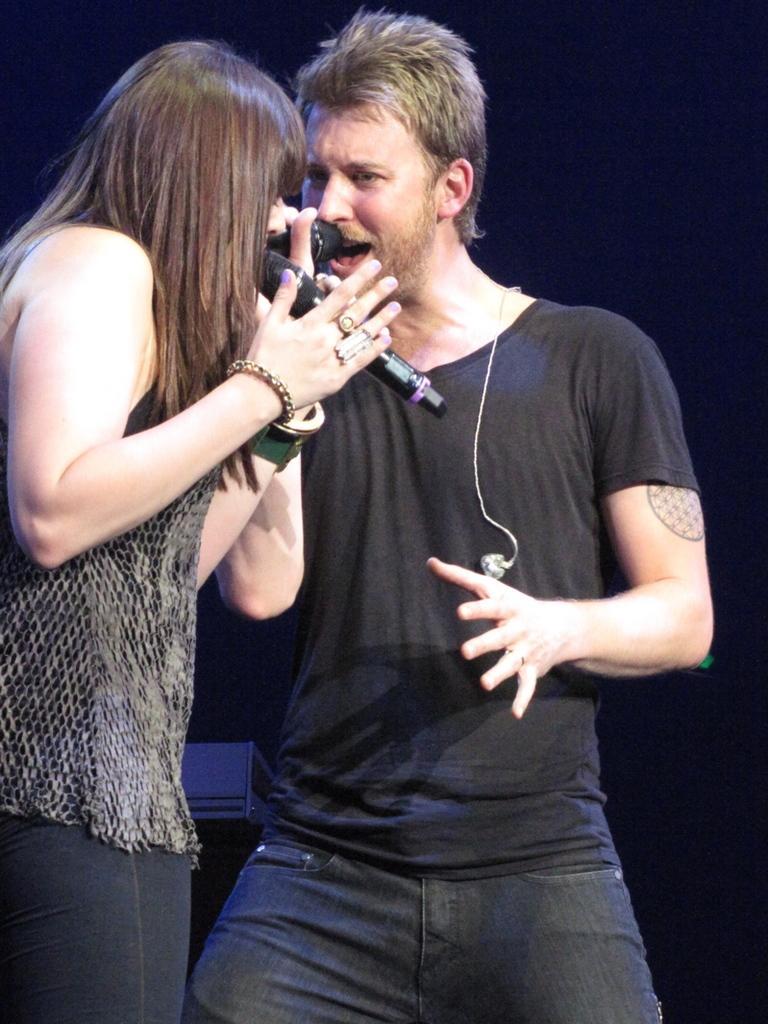Could you give a brief overview of what you see in this image? 2 people are standing and holding microphones. The person at the right is wearing a black t shirt and jeans. The background is black. 